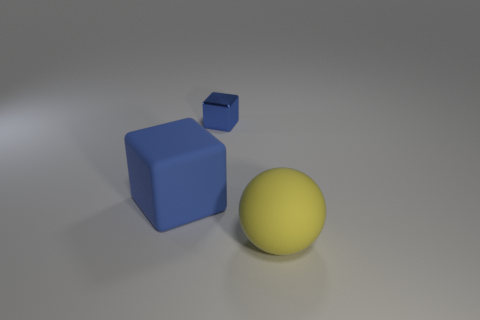Add 2 large red things. How many objects exist? 5 Subtract all balls. How many objects are left? 2 Subtract all small blue metallic things. Subtract all purple matte things. How many objects are left? 2 Add 3 big blue rubber objects. How many big blue rubber objects are left? 4 Add 3 large blocks. How many large blocks exist? 4 Subtract 0 green cubes. How many objects are left? 3 